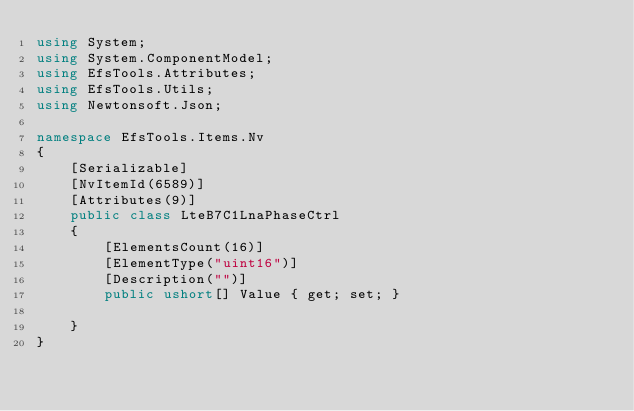<code> <loc_0><loc_0><loc_500><loc_500><_C#_>using System;
using System.ComponentModel;
using EfsTools.Attributes;
using EfsTools.Utils;
using Newtonsoft.Json;

namespace EfsTools.Items.Nv
{
    [Serializable]
    [NvItemId(6589)]
    [Attributes(9)]
    public class LteB7C1LnaPhaseCtrl
    {
        [ElementsCount(16)]
        [ElementType("uint16")]
        [Description("")]
        public ushort[] Value { get; set; }
        
    }
}
</code> 